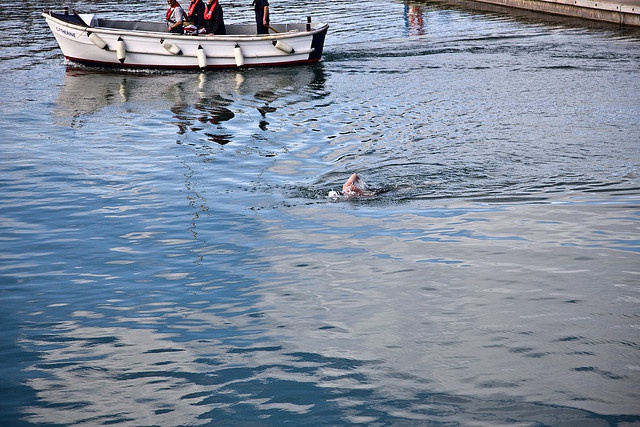Describe the objects in this image and their specific colors. I can see boat in black, lightgray, darkgray, and gray tones, people in black, red, salmon, and maroon tones, people in black, darkgray, lightgray, and gray tones, people in black, gray, maroon, and salmon tones, and people in black, salmon, maroon, and brown tones in this image. 